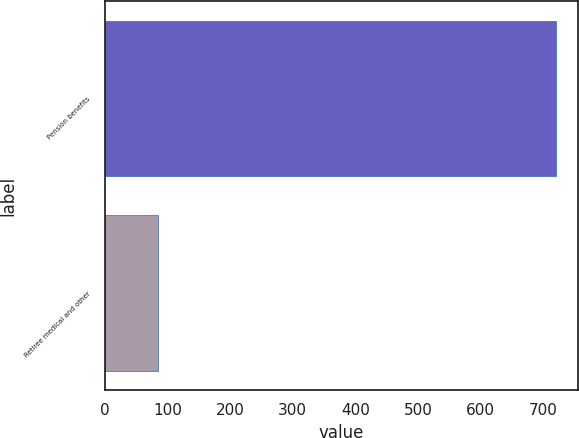Convert chart. <chart><loc_0><loc_0><loc_500><loc_500><bar_chart><fcel>Pension benefits<fcel>Retiree medical and other<nl><fcel>720<fcel>84<nl></chart> 